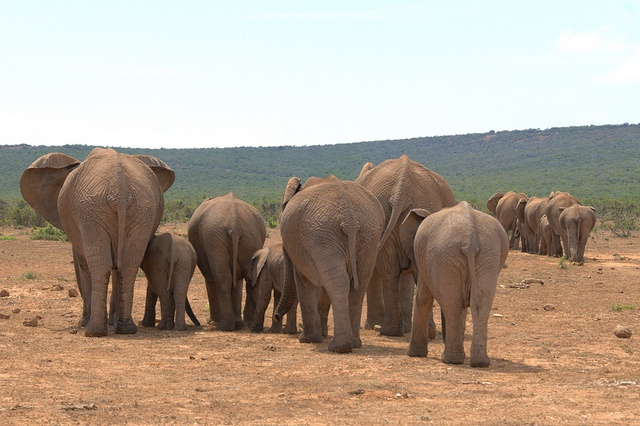Describe the objects in this image and their specific colors. I can see elephant in white, gray, and maroon tones, elephant in white, gray, and maroon tones, elephant in white, gray, brown, and maroon tones, elephant in white, maroon, and gray tones, and elephant in white, black, maroon, and gray tones in this image. 